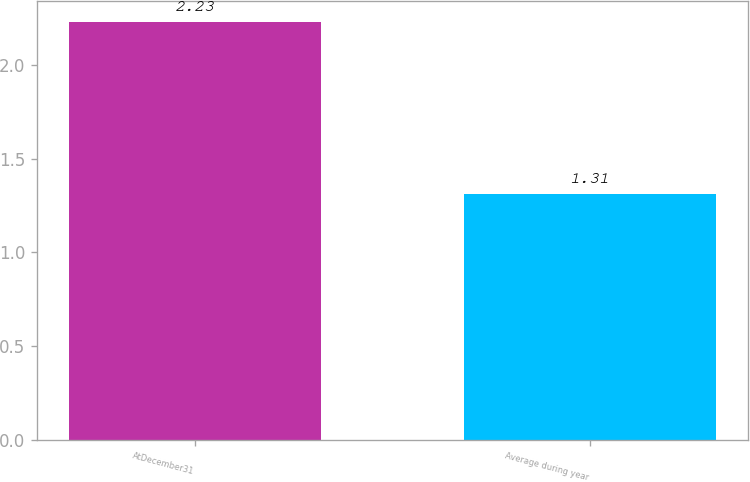Convert chart. <chart><loc_0><loc_0><loc_500><loc_500><bar_chart><fcel>AtDecember31<fcel>Average during year<nl><fcel>2.23<fcel>1.31<nl></chart> 